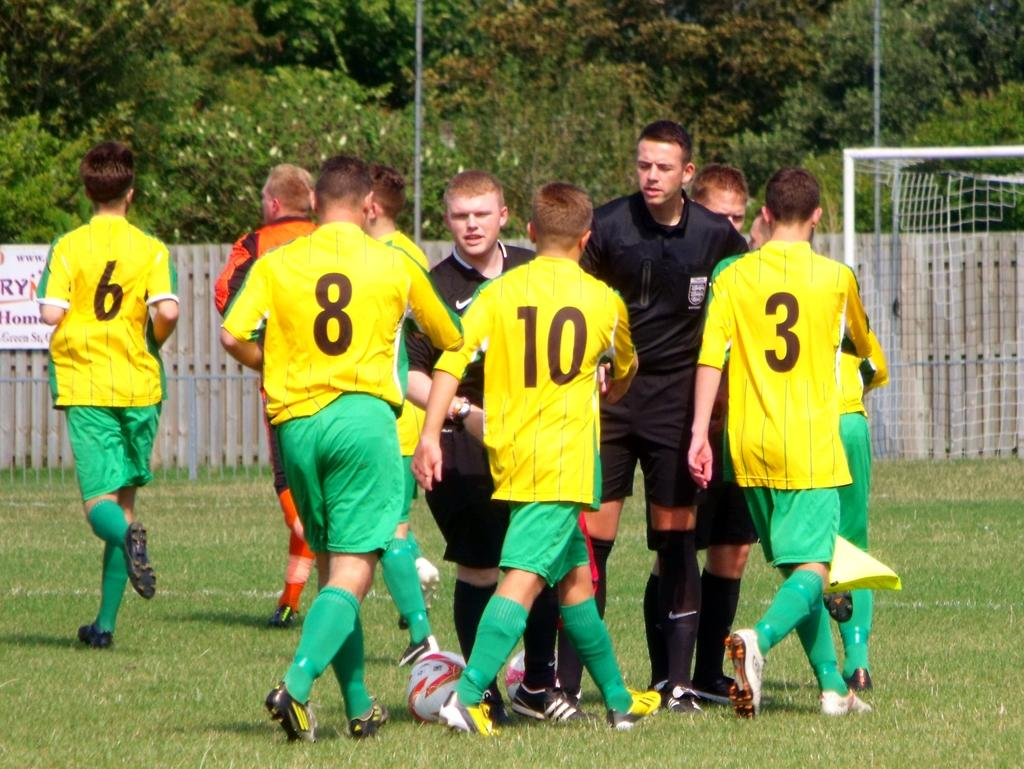How many people are in the image? There is a group of people in the image, but the exact number cannot be determined from the provided facts. What is on the ground in the image? There are balls on the ground in the image. What can be seen in the background of the image? In the background of the image, there is a fence, a net, a poster, iron poles, and trees. What might suggest that the group of people is participating in a sport or activity? The presence of balls, a net, and a fence in the background might suggest that the group of people is participating in a sport or activity. What type of milk is being served to the people in the image? There is no milk present in the image; it features a group of people, balls on the ground, and various items in the background. 